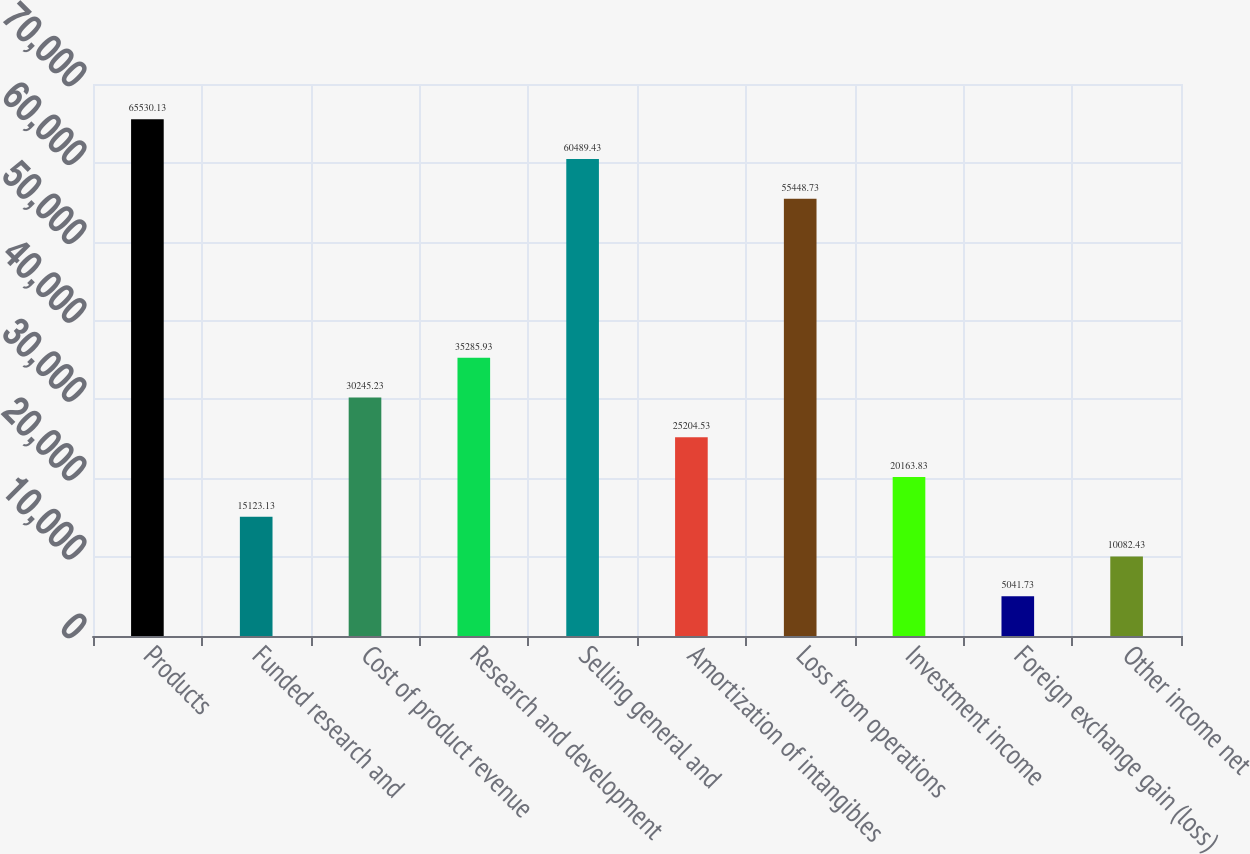Convert chart. <chart><loc_0><loc_0><loc_500><loc_500><bar_chart><fcel>Products<fcel>Funded research and<fcel>Cost of product revenue<fcel>Research and development<fcel>Selling general and<fcel>Amortization of intangibles<fcel>Loss from operations<fcel>Investment income<fcel>Foreign exchange gain (loss)<fcel>Other income net<nl><fcel>65530.1<fcel>15123.1<fcel>30245.2<fcel>35285.9<fcel>60489.4<fcel>25204.5<fcel>55448.7<fcel>20163.8<fcel>5041.73<fcel>10082.4<nl></chart> 